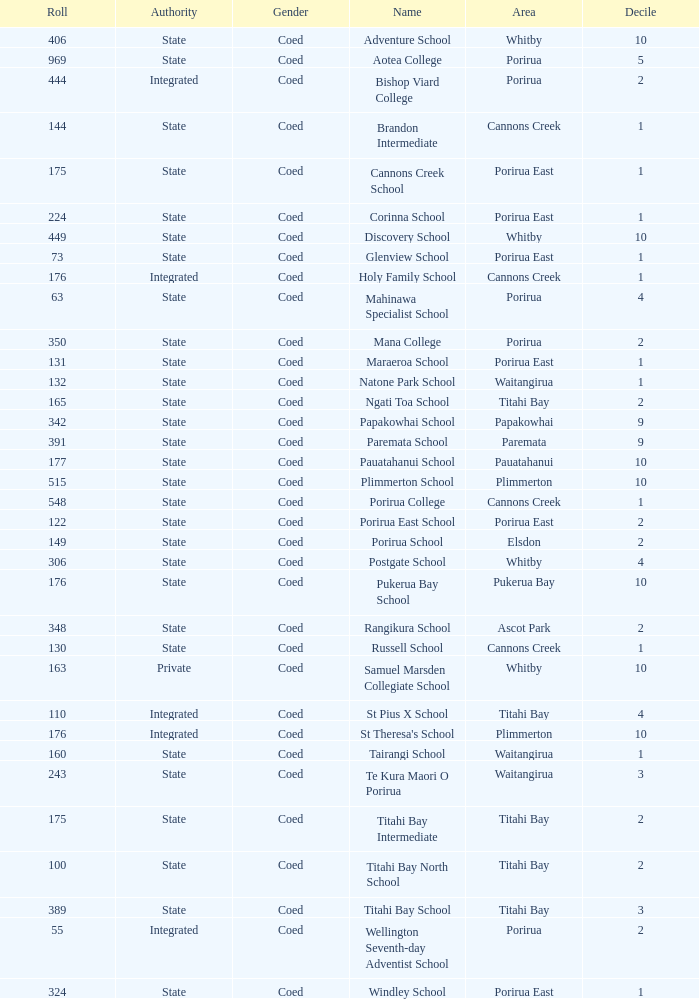What is the roll of Bishop Viard College (An Integrated College), which has a decile larger than 1? 1.0. 